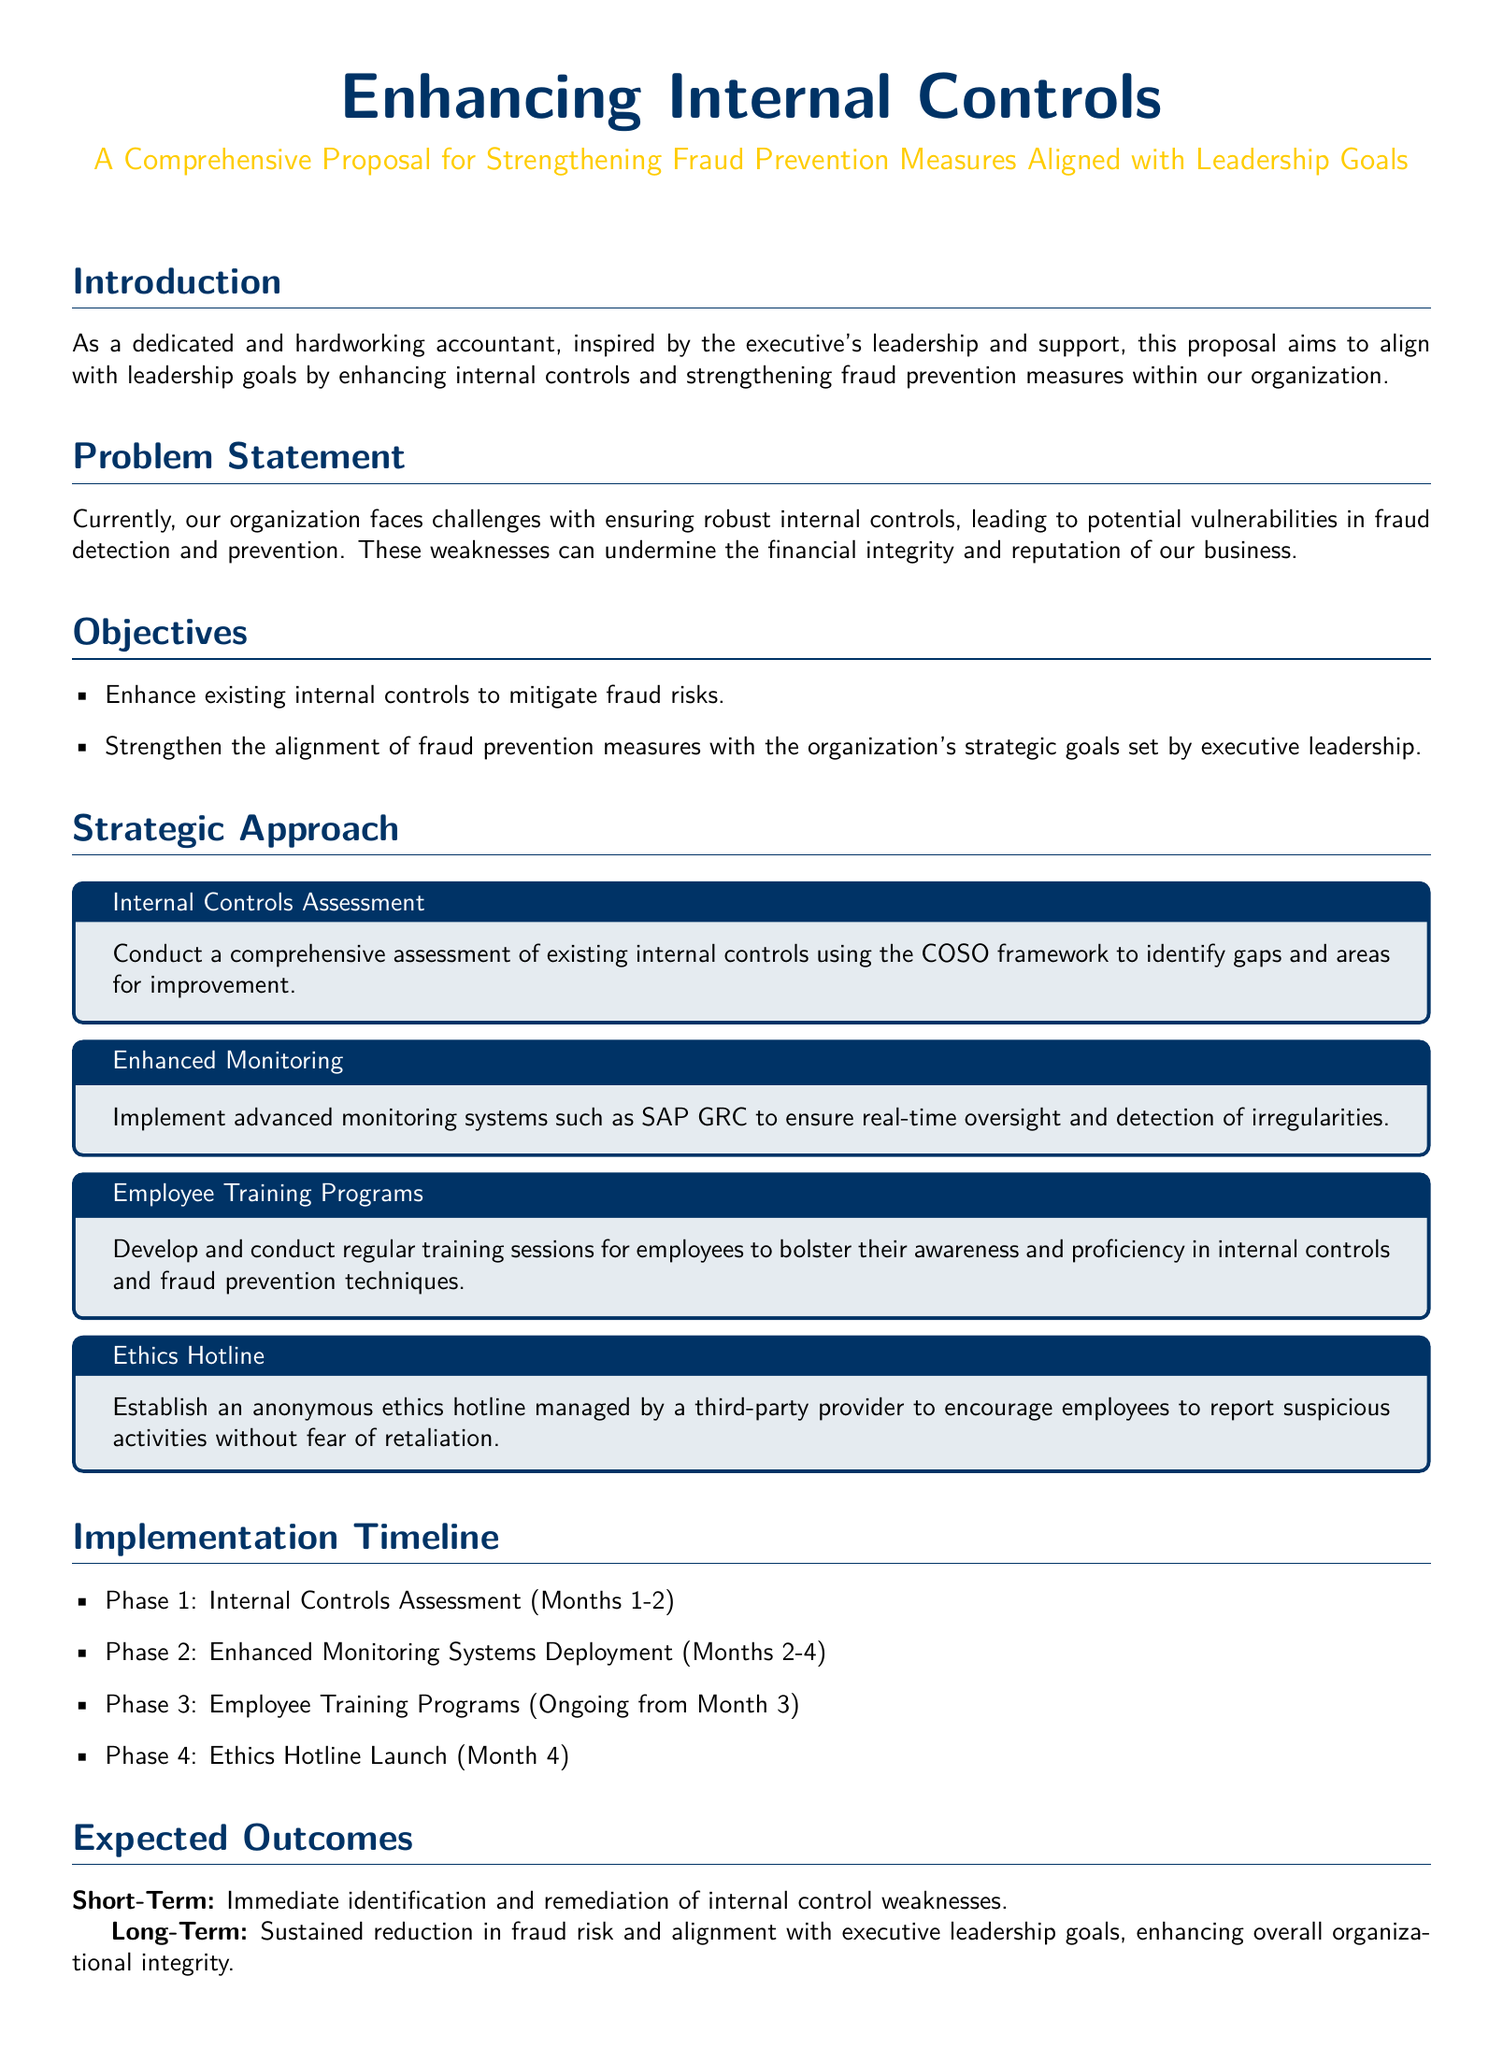What is the title of the proposal? The title of the proposal is presented prominently in the document, indicating its focus on internal controls and fraud prevention.
Answer: Enhancing Internal Controls What is the main objective of the proposal? The main objective of the proposal is specified in the objectives section and focuses on improving internal controls and fraud prevention measures.
Answer: Enhance existing internal controls to mitigate fraud risks What framework will be used for the internal controls assessment? The framework to be used for assessment is mentioned in the strategic approach, indicating a structured method.
Answer: COSO framework What advanced system will be implemented for monitoring? An advanced system is proposed for real-time oversight, which is crucial for fraud detection.
Answer: SAP GRC What is the expected outcome in the short term? The expected short-term outcome is outlined in the expected outcomes section, focusing on the immediate effects of the proposal.
Answer: Immediate identification and remediation of internal control weaknesses During which phase will the ethics hotline be launched? The timeline for the implementation details when the ethics hotline is scheduled to be introduced.
Answer: Month 4 What does the proposal aim to enhance alongside fraud prevention measures? The alignment with executive leadership goals is a key focus in the proposal, indicating strategic consistency.
Answer: Alignment with executive leadership goals How long will the employee training programs occur? The frequency of employee training programs is described, indicating an ongoing commitment to training.
Answer: Ongoing from Month 3 What color scheme is utilized for the document's sections? The document uses a consistent color scheme reflected in the titles, enhancing visual organization.
Answer: Main color and second color 